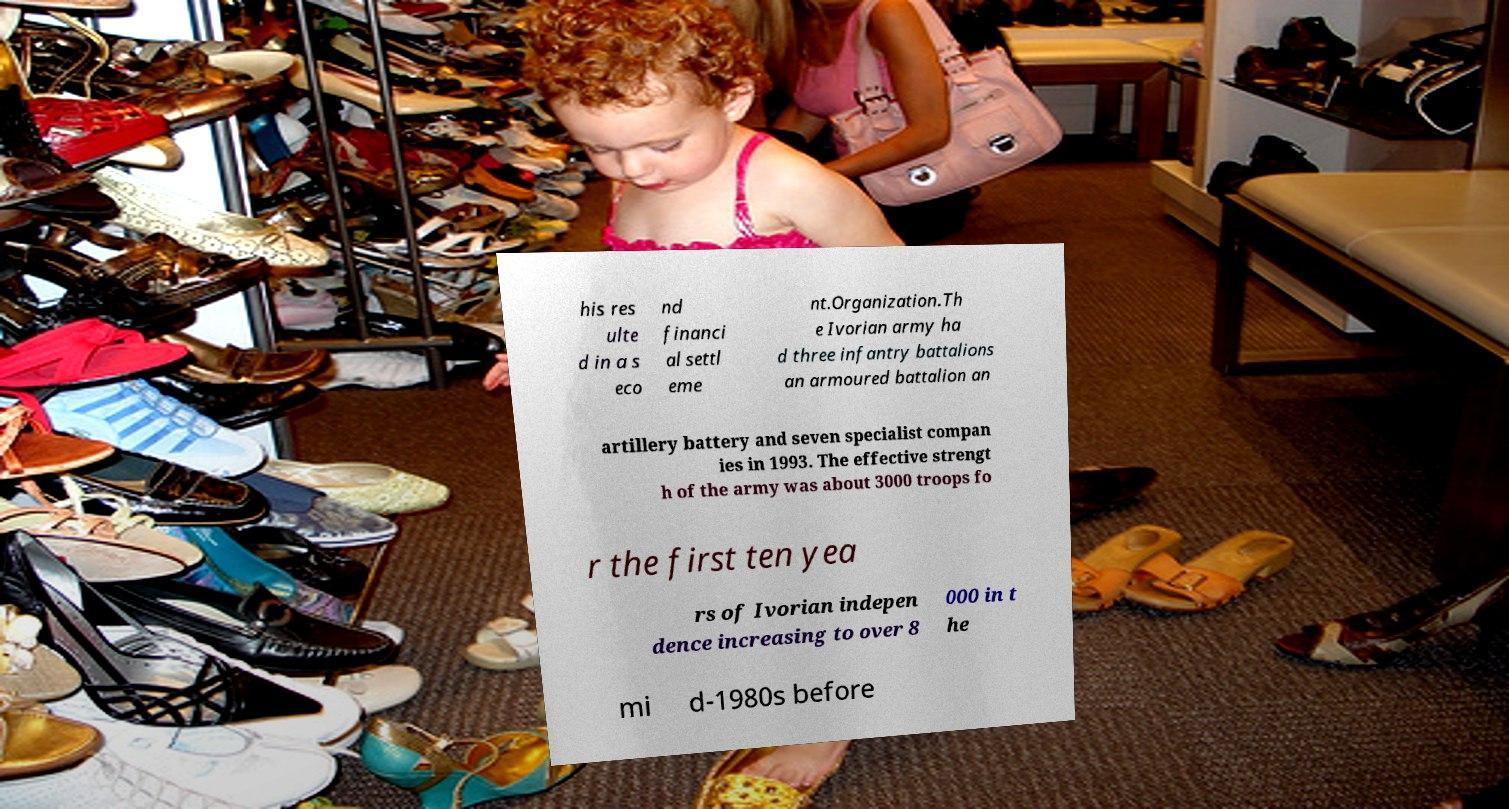There's text embedded in this image that I need extracted. Can you transcribe it verbatim? his res ulte d in a s eco nd financi al settl eme nt.Organization.Th e Ivorian army ha d three infantry battalions an armoured battalion an artillery battery and seven specialist compan ies in 1993. The effective strengt h of the army was about 3000 troops fo r the first ten yea rs of Ivorian indepen dence increasing to over 8 000 in t he mi d-1980s before 